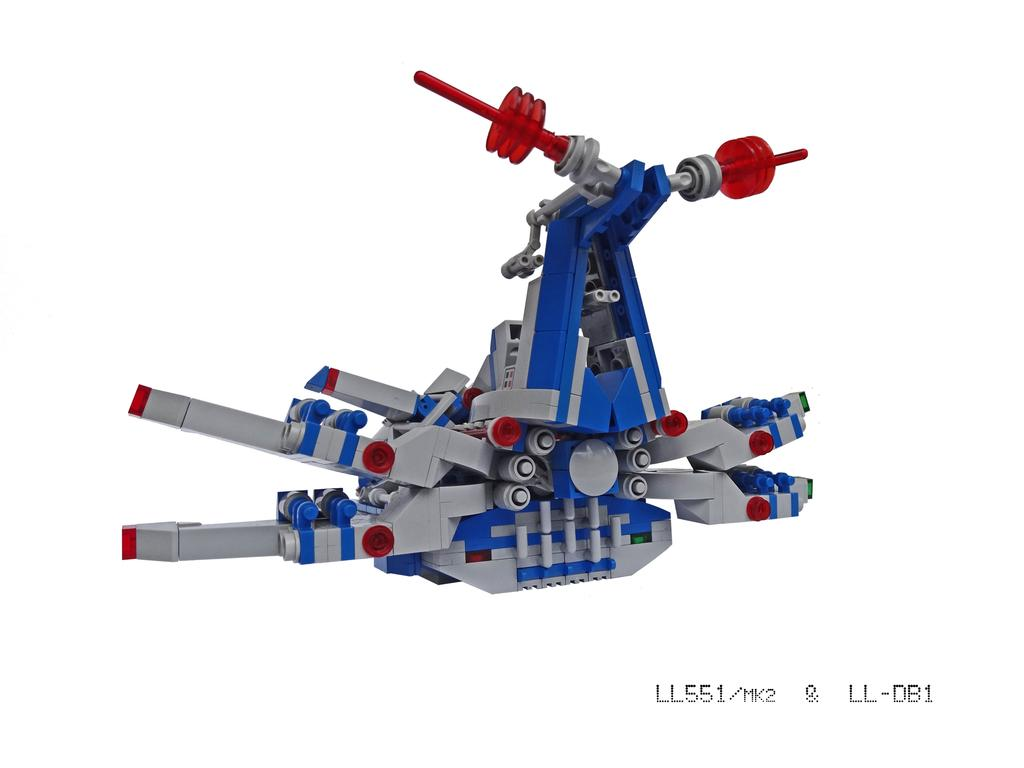What is the main subject of the image? There is a Lego in the image. What color is the background of the image? The background of the image is white. Is there any text present in the image? Yes, there is text at the bottom of the image. Can you tell me how many people are taking a bath in the image? There is no indication of a bath or people taking a bath in the image; it features a Lego and a white background with text at the bottom. What type of development is shown in the image? There is no development or construction project depicted in the image; it features a Lego and a white background with text at the bottom. 